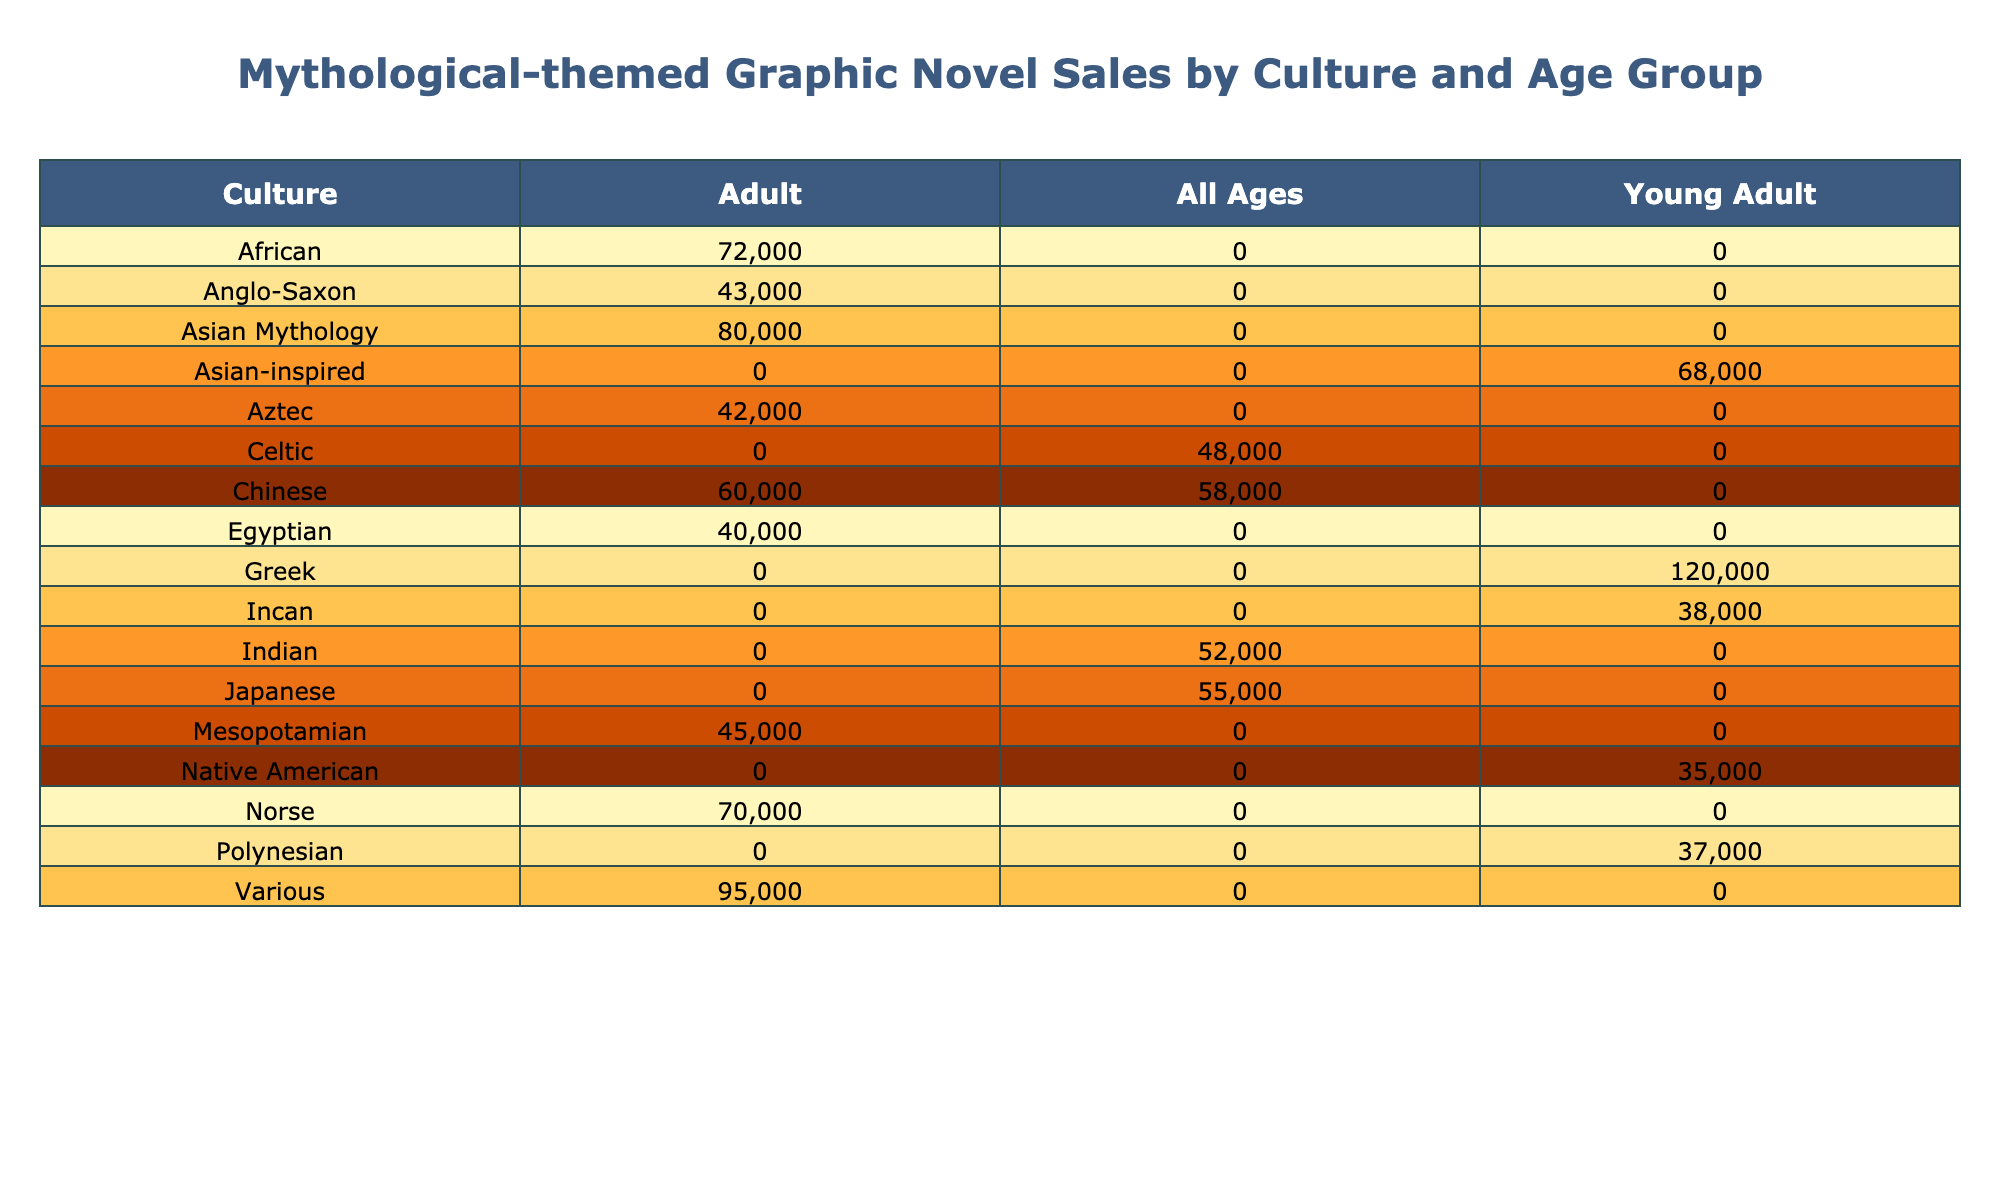What culture has the highest total sales for young adult graphic novels? In the table, looking at the sales figures for the young adult category, the Greek culture has the highest sales at 62,000. Other cultures do not exceed this figure in the young adult category.
Answer: Greek What is the total sales for adult graphic novels from Asian mythology? The relevant entry in the table indicates that "Monstress" is the only Asian mythology graphic novel listed under the adult category, with sales of 80,000. Therefore, the total sales for adult graphic novels from this culture is simply 80,000.
Answer: 80,000 Is there any culture that has zero sales recorded for adult graphic novels? By reviewing the adult sales figures in the table, all cultures listed have recorded sales amounts greater than zero, confirming that no culture has zero sales in the adult graphic novel category.
Answer: No Which culture has the most significant difference in sales between young adult and adult graphic novels? To find the culture with the most significant difference, we need to calculate the difference in sales for each culture that has entries in both categories. The highest difference is for the Norse culture, which has 70,000 sales (adult) and 0 (young adult), resulting in a difference of 70,000.
Answer: Norse What is the total sales for all ages graphic novels? The cultures with all ages graphic novels are Chinese, Indian, and Celtic. Their respective sales figures are 58,000, 52,000, and 48,000. Adding these figures together gives us a total of 58,000 + 52,000 + 48,000 = 158,000.
Answer: 158,000 